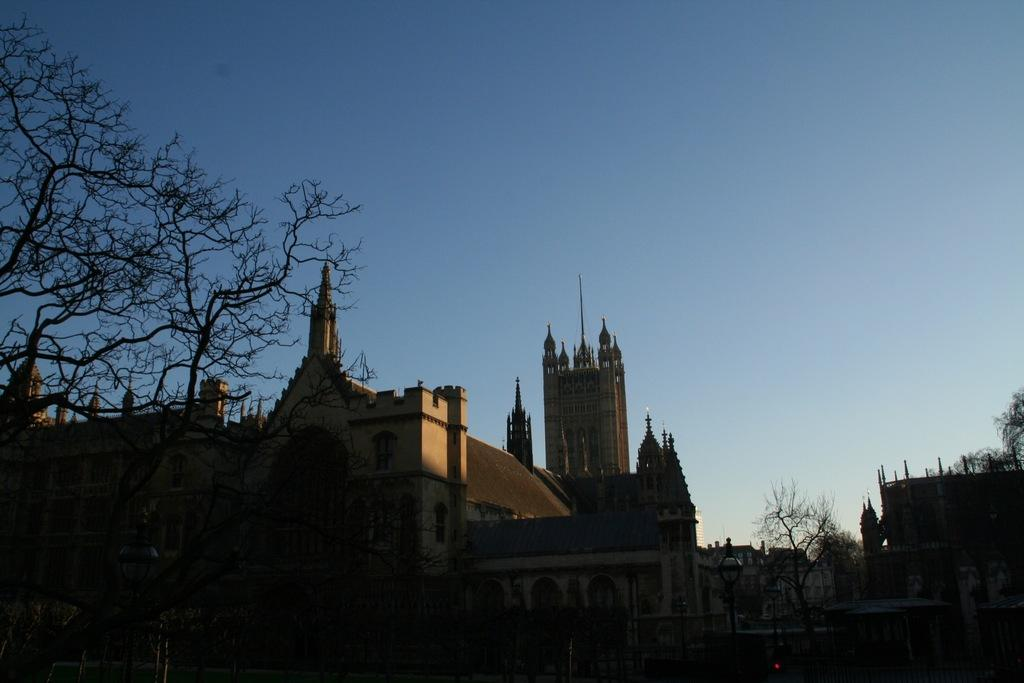What type of vegetation can be seen in the image? There are trees in the image. What type of man-made structures are present in the image? There are buildings in the image. What is visible at the top of the image? The sky is visible at the top of the image, and it is clear. How many cars can be seen parked near the trees in the image? There are no cars present in the image. Can you see a robin perched on one of the branches of the trees in the image? There is no robin visible in the image. What color is the stomach of the person standing near the buildings in the image? There is no person visible in the image, and therefore no stomach to describe. 